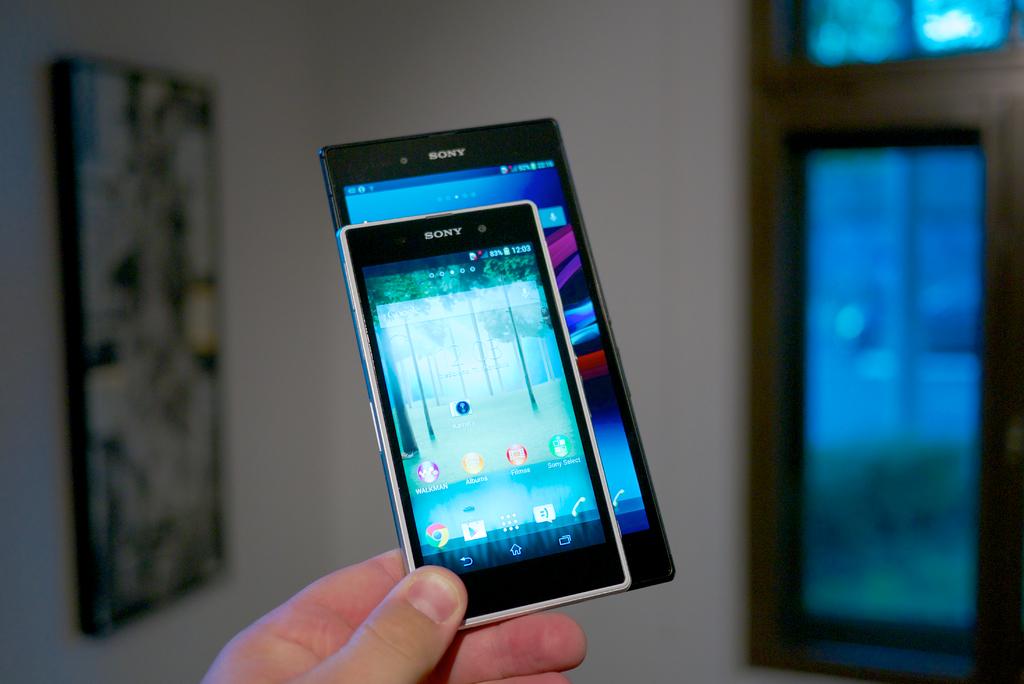Who is the maker of the phones?
Your answer should be very brief. Sony. Who makes these phones?
Your answer should be very brief. Sony. 